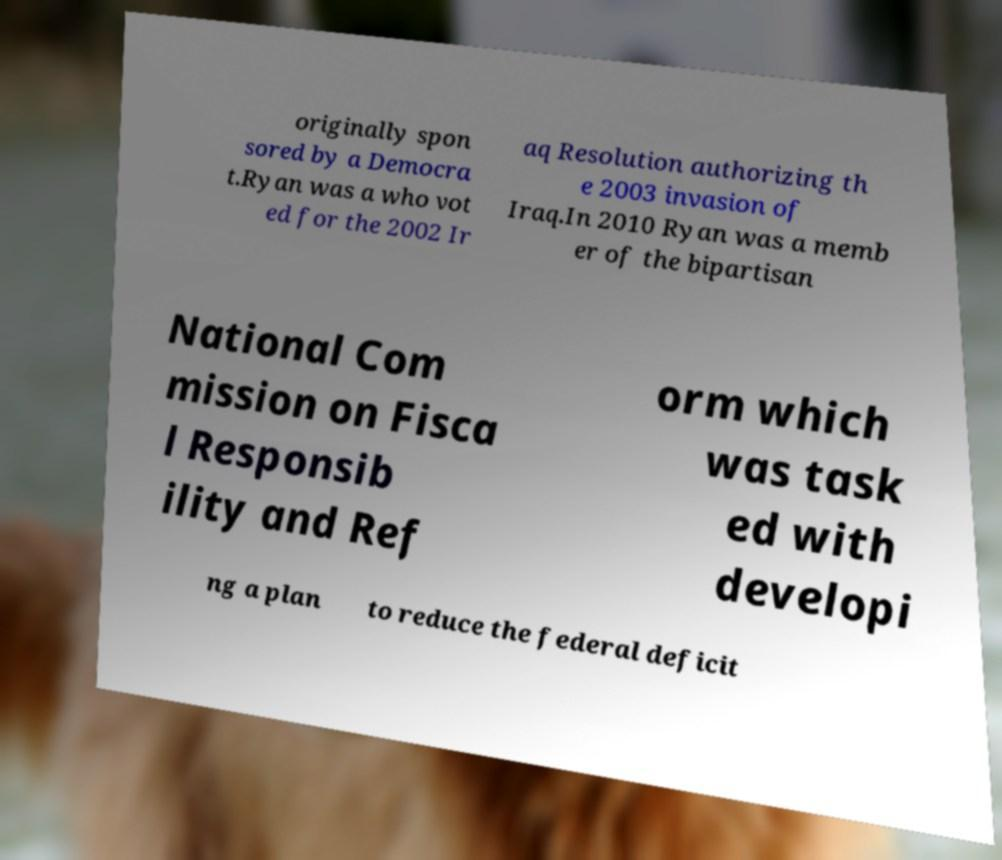There's text embedded in this image that I need extracted. Can you transcribe it verbatim? originally spon sored by a Democra t.Ryan was a who vot ed for the 2002 Ir aq Resolution authorizing th e 2003 invasion of Iraq.In 2010 Ryan was a memb er of the bipartisan National Com mission on Fisca l Responsib ility and Ref orm which was task ed with developi ng a plan to reduce the federal deficit 